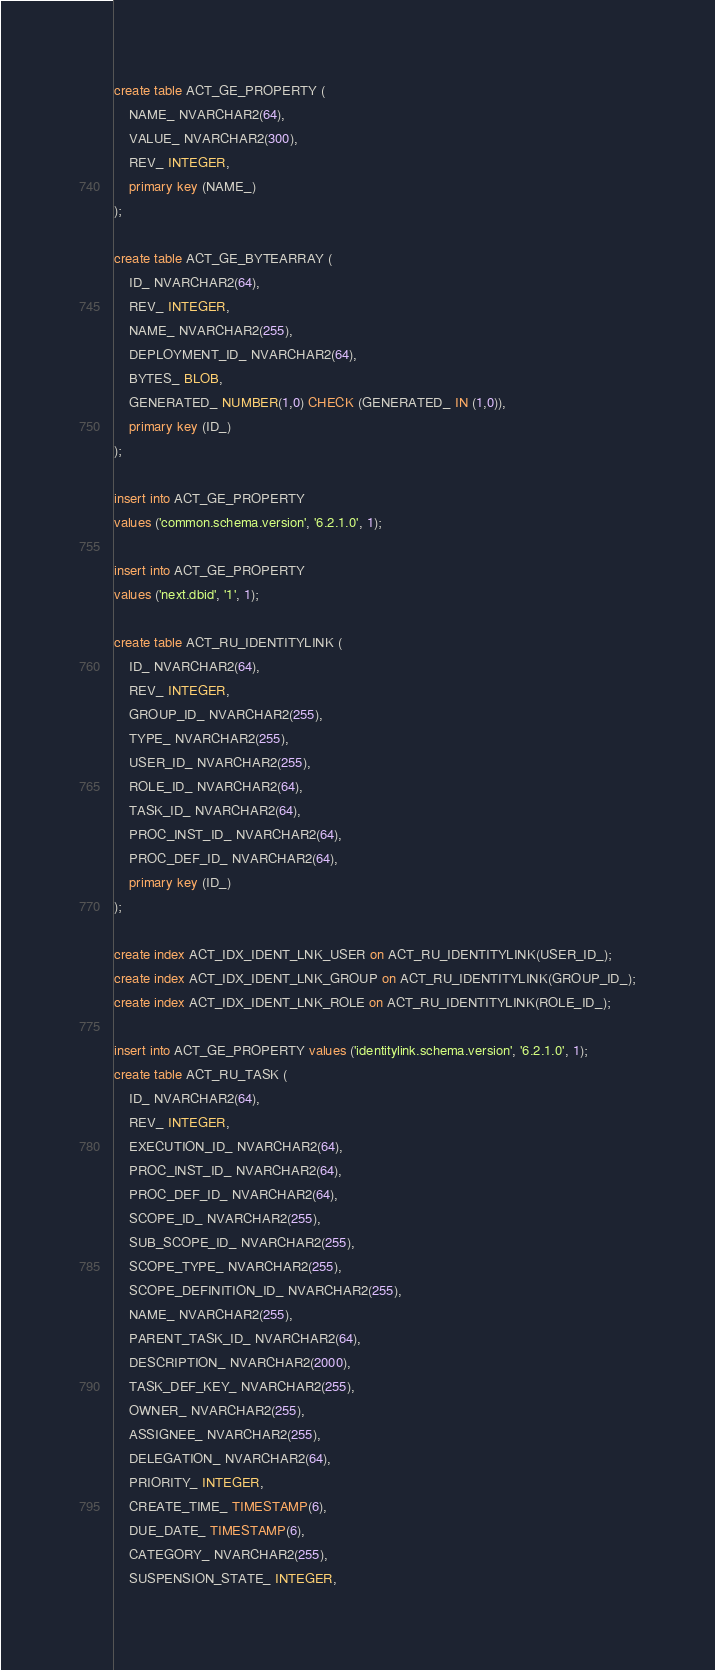<code> <loc_0><loc_0><loc_500><loc_500><_SQL_>create table ACT_GE_PROPERTY (
    NAME_ NVARCHAR2(64),
    VALUE_ NVARCHAR2(300),
    REV_ INTEGER,
    primary key (NAME_)
);

create table ACT_GE_BYTEARRAY (
    ID_ NVARCHAR2(64),
    REV_ INTEGER,
    NAME_ NVARCHAR2(255),
    DEPLOYMENT_ID_ NVARCHAR2(64),
    BYTES_ BLOB,
    GENERATED_ NUMBER(1,0) CHECK (GENERATED_ IN (1,0)),
    primary key (ID_)
);

insert into ACT_GE_PROPERTY
values ('common.schema.version', '6.2.1.0', 1);

insert into ACT_GE_PROPERTY
values ('next.dbid', '1', 1);

create table ACT_RU_IDENTITYLINK (
    ID_ NVARCHAR2(64),
    REV_ INTEGER,
    GROUP_ID_ NVARCHAR2(255),
    TYPE_ NVARCHAR2(255),
    USER_ID_ NVARCHAR2(255),
    ROLE_ID_ NVARCHAR2(64),
    TASK_ID_ NVARCHAR2(64),
    PROC_INST_ID_ NVARCHAR2(64),
    PROC_DEF_ID_ NVARCHAR2(64),
    primary key (ID_)
);

create index ACT_IDX_IDENT_LNK_USER on ACT_RU_IDENTITYLINK(USER_ID_);
create index ACT_IDX_IDENT_LNK_GROUP on ACT_RU_IDENTITYLINK(GROUP_ID_);
create index ACT_IDX_IDENT_LNK_ROLE on ACT_RU_IDENTITYLINK(ROLE_ID_);

insert into ACT_GE_PROPERTY values ('identitylink.schema.version', '6.2.1.0', 1);
create table ACT_RU_TASK (
    ID_ NVARCHAR2(64),
    REV_ INTEGER,
    EXECUTION_ID_ NVARCHAR2(64),
    PROC_INST_ID_ NVARCHAR2(64),
    PROC_DEF_ID_ NVARCHAR2(64),
    SCOPE_ID_ NVARCHAR2(255),
    SUB_SCOPE_ID_ NVARCHAR2(255),
    SCOPE_TYPE_ NVARCHAR2(255),
    SCOPE_DEFINITION_ID_ NVARCHAR2(255),
    NAME_ NVARCHAR2(255),
    PARENT_TASK_ID_ NVARCHAR2(64),
    DESCRIPTION_ NVARCHAR2(2000),
    TASK_DEF_KEY_ NVARCHAR2(255),
    OWNER_ NVARCHAR2(255),
    ASSIGNEE_ NVARCHAR2(255),
    DELEGATION_ NVARCHAR2(64),
    PRIORITY_ INTEGER,
    CREATE_TIME_ TIMESTAMP(6),
    DUE_DATE_ TIMESTAMP(6),
    CATEGORY_ NVARCHAR2(255),
    SUSPENSION_STATE_ INTEGER,</code> 